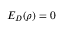Convert formula to latex. <formula><loc_0><loc_0><loc_500><loc_500>E _ { D } ( \rho ) = 0</formula> 